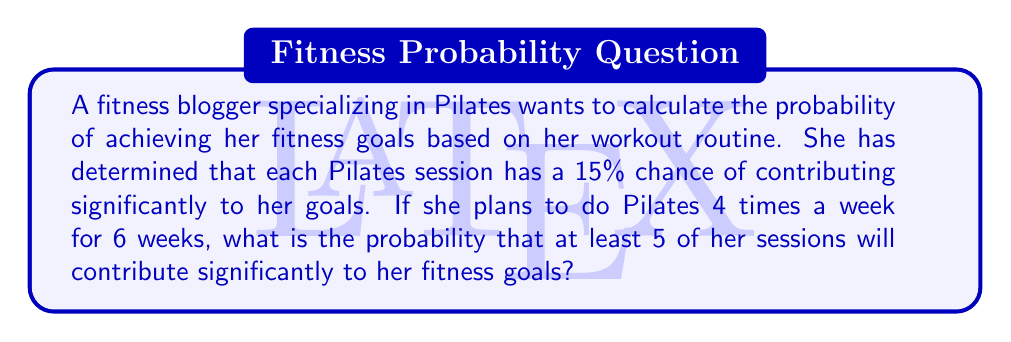Could you help me with this problem? To solve this problem, we can use the binomial probability distribution.

Let's define our variables:
$n$ = total number of trials (Pilates sessions)
$p$ = probability of success for each trial
$k$ = minimum number of successes we're interested in

1. Calculate $n$:
   $n = 4 \text{ sessions/week} \times 6 \text{ weeks} = 24 \text{ sessions}$

2. We know $p = 15\% = 0.15$

3. We want the probability of at least 5 successes, so we need to calculate:
   $P(X \geq 5) = 1 - P(X < 5) = 1 - P(X \leq 4)$

4. Using the cumulative binomial probability formula:

   $$P(X \leq k) = \sum_{i=0}^k \binom{n}{i} p^i (1-p)^{n-i}$$

   We need to calculate:

   $$1 - \sum_{i=0}^4 \binom{24}{i} (0.15)^i (0.85)^{24-i}$$

5. Expanding this:

   $$1 - [\binom{24}{0}(0.15)^0(0.85)^{24} + \binom{24}{1}(0.15)^1(0.85)^{23} + \binom{24}{2}(0.15)^2(0.85)^{22} + \binom{24}{3}(0.15)^3(0.85)^{21} + \binom{24}{4}(0.15)^4(0.85)^{20}]$$

6. Calculating each term:
   
   $\binom{24}{0}(0.15)^0(0.85)^{24} \approx 0.0157$
   $\binom{24}{1}(0.15)^1(0.85)^{23} \approx 0.0666$
   $\binom{24}{2}(0.15)^2(0.85)^{22} \approx 0.1351$
   $\binom{24}{3}(0.15)^3(0.85)^{21} \approx 0.1726$
   $\binom{24}{4}(0.15)^4(0.85)^{20} \approx 0.1681$

7. Sum these probabilities:
   $0.0157 + 0.0666 + 0.1351 + 0.1726 + 0.1681 = 0.5581$

8. Subtract from 1:
   $1 - 0.5581 = 0.4419$

Therefore, the probability of at least 5 sessions contributing significantly to her fitness goals is approximately 0.4419 or 44.19%.
Answer: The probability is approximately 0.4419 or 44.19%. 